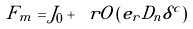<formula> <loc_0><loc_0><loc_500><loc_500>F _ { m } = J _ { 0 } + \ r O \left ( e _ { r } D _ { n } \delta ^ { c } \right )</formula> 